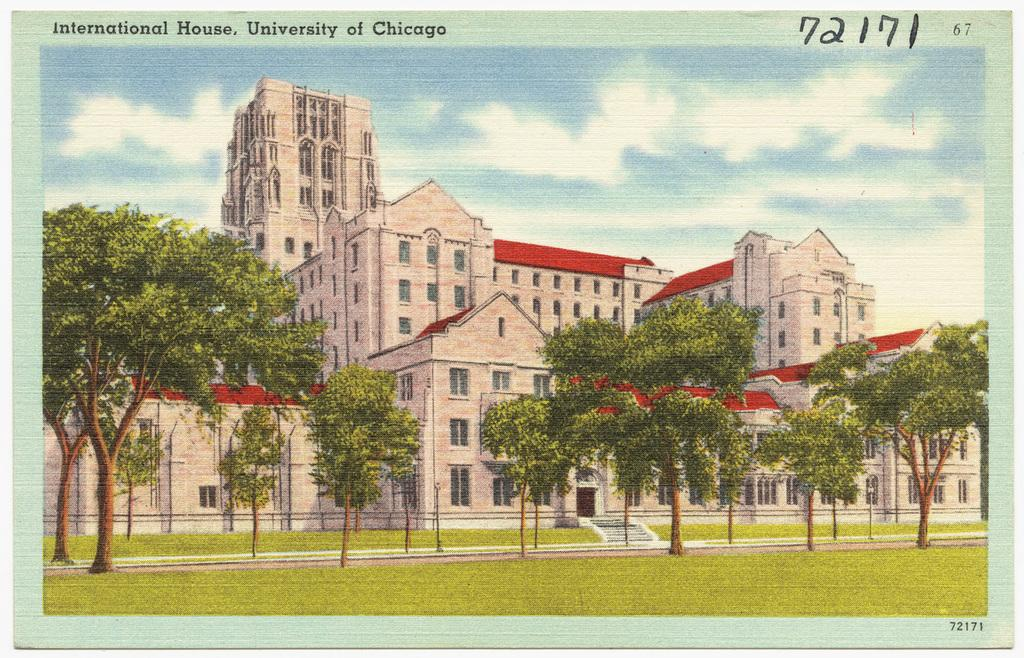What type of visual is the image? The image is a poster. What structures are depicted on the poster? There are buildings depicted on the poster. What type of natural elements are depicted on the poster? There are trees depicted on the poster. What part of the natural environment is visible on the poster? The sky is visible on the poster. How does the poster show respect to the sister? The poster does not show respect to a sister, as it is a visual representation of buildings, trees, and the sky. Is there a mask visible on the poster? There is no mask present on the poster. 